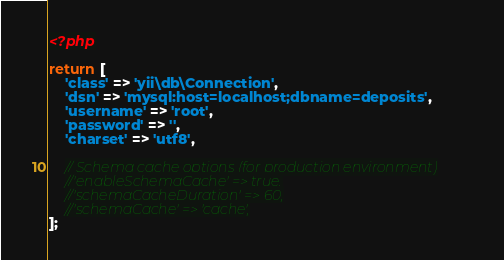<code> <loc_0><loc_0><loc_500><loc_500><_PHP_><?php

return [
    'class' => 'yii\db\Connection',
    'dsn' => 'mysql:host=localhost;dbname=deposits',
    'username' => 'root',
    'password' => '',
    'charset' => 'utf8',

    // Schema cache options (for production environment)
    //'enableSchemaCache' => true,
    //'schemaCacheDuration' => 60,
    //'schemaCache' => 'cache',
];
</code> 